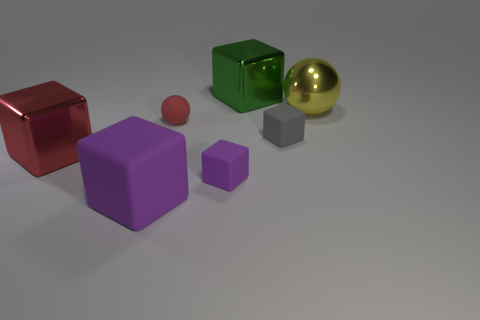Are there more red objects that are on the left side of the tiny matte ball than large gray metallic blocks?
Offer a very short reply. Yes. The large thing that is to the left of the large yellow metallic sphere and right of the small purple matte block is made of what material?
Give a very brief answer. Metal. Is there any other thing that has the same shape as the tiny red rubber object?
Provide a short and direct response. Yes. How many large things are both left of the large yellow metallic object and behind the big purple matte cube?
Provide a succinct answer. 2. What is the material of the yellow object?
Ensure brevity in your answer.  Metal. Are there an equal number of red metal blocks that are on the right side of the large yellow metallic thing and large green blocks?
Ensure brevity in your answer.  No. How many green things have the same shape as the tiny purple matte thing?
Offer a very short reply. 1. Do the small purple matte object and the yellow thing have the same shape?
Ensure brevity in your answer.  No. How many objects are either big metal cubes on the right side of the red block or objects?
Keep it short and to the point. 7. There is a red object that is on the right side of the large object that is in front of the block that is on the left side of the big purple object; what is its shape?
Offer a terse response. Sphere. 